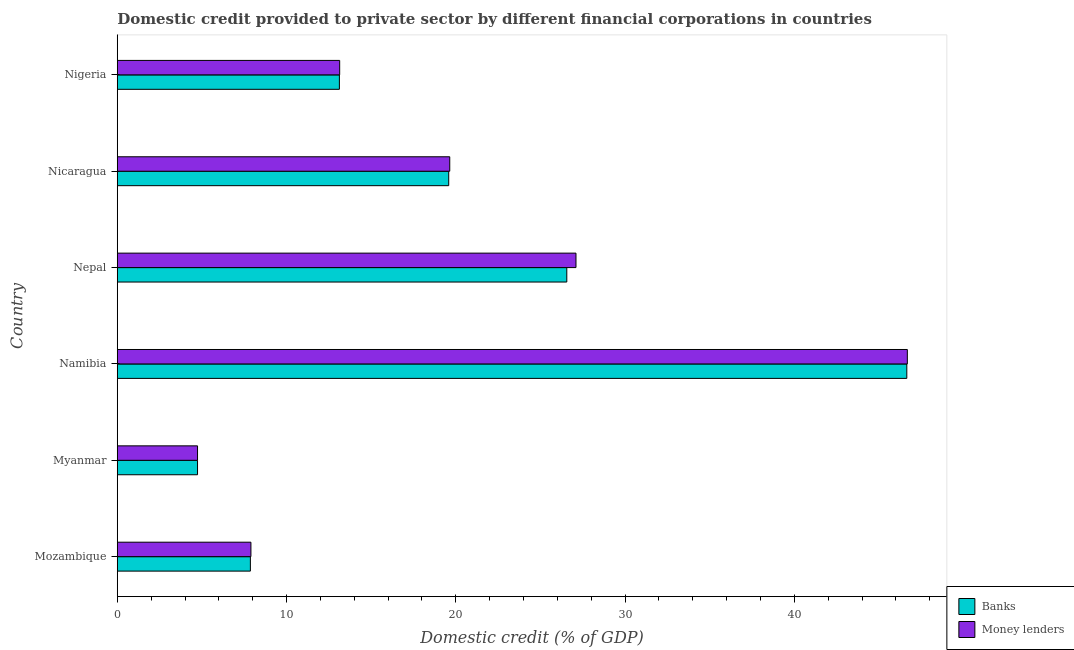How many different coloured bars are there?
Keep it short and to the point. 2. How many groups of bars are there?
Provide a short and direct response. 6. Are the number of bars per tick equal to the number of legend labels?
Provide a succinct answer. Yes. Are the number of bars on each tick of the Y-axis equal?
Provide a short and direct response. Yes. What is the label of the 6th group of bars from the top?
Offer a very short reply. Mozambique. In how many cases, is the number of bars for a given country not equal to the number of legend labels?
Ensure brevity in your answer.  0. What is the domestic credit provided by banks in Nicaragua?
Your answer should be compact. 19.58. Across all countries, what is the maximum domestic credit provided by money lenders?
Your response must be concise. 46.67. Across all countries, what is the minimum domestic credit provided by banks?
Give a very brief answer. 4.74. In which country was the domestic credit provided by money lenders maximum?
Keep it short and to the point. Namibia. In which country was the domestic credit provided by banks minimum?
Provide a short and direct response. Myanmar. What is the total domestic credit provided by money lenders in the graph?
Make the answer very short. 119.18. What is the difference between the domestic credit provided by banks in Mozambique and that in Nigeria?
Offer a terse response. -5.26. What is the difference between the domestic credit provided by money lenders in Nicaragua and the domestic credit provided by banks in Myanmar?
Your answer should be very brief. 14.9. What is the average domestic credit provided by money lenders per country?
Ensure brevity in your answer.  19.86. What is the difference between the domestic credit provided by money lenders and domestic credit provided by banks in Myanmar?
Provide a short and direct response. 0. What is the ratio of the domestic credit provided by money lenders in Myanmar to that in Namibia?
Your answer should be very brief. 0.1. Is the domestic credit provided by money lenders in Mozambique less than that in Nepal?
Provide a succinct answer. Yes. Is the difference between the domestic credit provided by money lenders in Mozambique and Myanmar greater than the difference between the domestic credit provided by banks in Mozambique and Myanmar?
Your answer should be very brief. Yes. What is the difference between the highest and the second highest domestic credit provided by banks?
Your answer should be very brief. 20.09. What is the difference between the highest and the lowest domestic credit provided by banks?
Make the answer very short. 41.9. Is the sum of the domestic credit provided by banks in Namibia and Nigeria greater than the maximum domestic credit provided by money lenders across all countries?
Your answer should be very brief. Yes. What does the 1st bar from the top in Myanmar represents?
Ensure brevity in your answer.  Money lenders. What does the 2nd bar from the bottom in Mozambique represents?
Provide a short and direct response. Money lenders. What is the difference between two consecutive major ticks on the X-axis?
Provide a short and direct response. 10. Does the graph contain any zero values?
Keep it short and to the point. No. Where does the legend appear in the graph?
Offer a terse response. Bottom right. How many legend labels are there?
Ensure brevity in your answer.  2. What is the title of the graph?
Your answer should be very brief. Domestic credit provided to private sector by different financial corporations in countries. What is the label or title of the X-axis?
Ensure brevity in your answer.  Domestic credit (% of GDP). What is the label or title of the Y-axis?
Your answer should be very brief. Country. What is the Domestic credit (% of GDP) in Banks in Mozambique?
Provide a succinct answer. 7.86. What is the Domestic credit (% of GDP) in Money lenders in Mozambique?
Your answer should be compact. 7.89. What is the Domestic credit (% of GDP) in Banks in Myanmar?
Your response must be concise. 4.74. What is the Domestic credit (% of GDP) in Money lenders in Myanmar?
Offer a terse response. 4.74. What is the Domestic credit (% of GDP) in Banks in Namibia?
Provide a succinct answer. 46.64. What is the Domestic credit (% of GDP) in Money lenders in Namibia?
Your response must be concise. 46.67. What is the Domestic credit (% of GDP) in Banks in Nepal?
Give a very brief answer. 26.55. What is the Domestic credit (% of GDP) of Money lenders in Nepal?
Provide a succinct answer. 27.1. What is the Domestic credit (% of GDP) in Banks in Nicaragua?
Your answer should be very brief. 19.58. What is the Domestic credit (% of GDP) in Money lenders in Nicaragua?
Offer a terse response. 19.64. What is the Domestic credit (% of GDP) of Banks in Nigeria?
Your answer should be compact. 13.12. What is the Domestic credit (% of GDP) of Money lenders in Nigeria?
Keep it short and to the point. 13.14. Across all countries, what is the maximum Domestic credit (% of GDP) in Banks?
Your response must be concise. 46.64. Across all countries, what is the maximum Domestic credit (% of GDP) in Money lenders?
Ensure brevity in your answer.  46.67. Across all countries, what is the minimum Domestic credit (% of GDP) in Banks?
Ensure brevity in your answer.  4.74. Across all countries, what is the minimum Domestic credit (% of GDP) in Money lenders?
Provide a succinct answer. 4.74. What is the total Domestic credit (% of GDP) in Banks in the graph?
Ensure brevity in your answer.  118.5. What is the total Domestic credit (% of GDP) of Money lenders in the graph?
Provide a succinct answer. 119.18. What is the difference between the Domestic credit (% of GDP) of Banks in Mozambique and that in Myanmar?
Ensure brevity in your answer.  3.12. What is the difference between the Domestic credit (% of GDP) in Money lenders in Mozambique and that in Myanmar?
Make the answer very short. 3.15. What is the difference between the Domestic credit (% of GDP) in Banks in Mozambique and that in Namibia?
Your answer should be compact. -38.78. What is the difference between the Domestic credit (% of GDP) of Money lenders in Mozambique and that in Namibia?
Make the answer very short. -38.78. What is the difference between the Domestic credit (% of GDP) in Banks in Mozambique and that in Nepal?
Your answer should be compact. -18.69. What is the difference between the Domestic credit (% of GDP) in Money lenders in Mozambique and that in Nepal?
Provide a succinct answer. -19.2. What is the difference between the Domestic credit (% of GDP) of Banks in Mozambique and that in Nicaragua?
Give a very brief answer. -11.72. What is the difference between the Domestic credit (% of GDP) of Money lenders in Mozambique and that in Nicaragua?
Provide a short and direct response. -11.75. What is the difference between the Domestic credit (% of GDP) of Banks in Mozambique and that in Nigeria?
Your response must be concise. -5.26. What is the difference between the Domestic credit (% of GDP) in Money lenders in Mozambique and that in Nigeria?
Provide a short and direct response. -5.24. What is the difference between the Domestic credit (% of GDP) of Banks in Myanmar and that in Namibia?
Make the answer very short. -41.9. What is the difference between the Domestic credit (% of GDP) of Money lenders in Myanmar and that in Namibia?
Provide a short and direct response. -41.93. What is the difference between the Domestic credit (% of GDP) of Banks in Myanmar and that in Nepal?
Ensure brevity in your answer.  -21.81. What is the difference between the Domestic credit (% of GDP) of Money lenders in Myanmar and that in Nepal?
Your answer should be very brief. -22.36. What is the difference between the Domestic credit (% of GDP) of Banks in Myanmar and that in Nicaragua?
Your response must be concise. -14.84. What is the difference between the Domestic credit (% of GDP) in Money lenders in Myanmar and that in Nicaragua?
Offer a terse response. -14.9. What is the difference between the Domestic credit (% of GDP) in Banks in Myanmar and that in Nigeria?
Make the answer very short. -8.38. What is the difference between the Domestic credit (% of GDP) in Money lenders in Myanmar and that in Nigeria?
Your answer should be compact. -8.4. What is the difference between the Domestic credit (% of GDP) of Banks in Namibia and that in Nepal?
Provide a short and direct response. 20.09. What is the difference between the Domestic credit (% of GDP) of Money lenders in Namibia and that in Nepal?
Your answer should be very brief. 19.57. What is the difference between the Domestic credit (% of GDP) in Banks in Namibia and that in Nicaragua?
Offer a terse response. 27.06. What is the difference between the Domestic credit (% of GDP) in Money lenders in Namibia and that in Nicaragua?
Ensure brevity in your answer.  27.03. What is the difference between the Domestic credit (% of GDP) of Banks in Namibia and that in Nigeria?
Your answer should be very brief. 33.52. What is the difference between the Domestic credit (% of GDP) of Money lenders in Namibia and that in Nigeria?
Provide a short and direct response. 33.53. What is the difference between the Domestic credit (% of GDP) of Banks in Nepal and that in Nicaragua?
Your answer should be very brief. 6.98. What is the difference between the Domestic credit (% of GDP) in Money lenders in Nepal and that in Nicaragua?
Keep it short and to the point. 7.46. What is the difference between the Domestic credit (% of GDP) of Banks in Nepal and that in Nigeria?
Keep it short and to the point. 13.43. What is the difference between the Domestic credit (% of GDP) in Money lenders in Nepal and that in Nigeria?
Your answer should be compact. 13.96. What is the difference between the Domestic credit (% of GDP) of Banks in Nicaragua and that in Nigeria?
Your answer should be very brief. 6.46. What is the difference between the Domestic credit (% of GDP) in Money lenders in Nicaragua and that in Nigeria?
Provide a succinct answer. 6.5. What is the difference between the Domestic credit (% of GDP) of Banks in Mozambique and the Domestic credit (% of GDP) of Money lenders in Myanmar?
Offer a terse response. 3.12. What is the difference between the Domestic credit (% of GDP) of Banks in Mozambique and the Domestic credit (% of GDP) of Money lenders in Namibia?
Ensure brevity in your answer.  -38.81. What is the difference between the Domestic credit (% of GDP) of Banks in Mozambique and the Domestic credit (% of GDP) of Money lenders in Nepal?
Ensure brevity in your answer.  -19.24. What is the difference between the Domestic credit (% of GDP) in Banks in Mozambique and the Domestic credit (% of GDP) in Money lenders in Nicaragua?
Give a very brief answer. -11.78. What is the difference between the Domestic credit (% of GDP) in Banks in Mozambique and the Domestic credit (% of GDP) in Money lenders in Nigeria?
Keep it short and to the point. -5.28. What is the difference between the Domestic credit (% of GDP) in Banks in Myanmar and the Domestic credit (% of GDP) in Money lenders in Namibia?
Offer a terse response. -41.93. What is the difference between the Domestic credit (% of GDP) of Banks in Myanmar and the Domestic credit (% of GDP) of Money lenders in Nepal?
Give a very brief answer. -22.36. What is the difference between the Domestic credit (% of GDP) of Banks in Myanmar and the Domestic credit (% of GDP) of Money lenders in Nicaragua?
Offer a terse response. -14.9. What is the difference between the Domestic credit (% of GDP) in Banks in Myanmar and the Domestic credit (% of GDP) in Money lenders in Nigeria?
Provide a short and direct response. -8.4. What is the difference between the Domestic credit (% of GDP) in Banks in Namibia and the Domestic credit (% of GDP) in Money lenders in Nepal?
Your response must be concise. 19.54. What is the difference between the Domestic credit (% of GDP) of Banks in Namibia and the Domestic credit (% of GDP) of Money lenders in Nicaragua?
Keep it short and to the point. 27. What is the difference between the Domestic credit (% of GDP) in Banks in Namibia and the Domestic credit (% of GDP) in Money lenders in Nigeria?
Make the answer very short. 33.5. What is the difference between the Domestic credit (% of GDP) of Banks in Nepal and the Domestic credit (% of GDP) of Money lenders in Nicaragua?
Your response must be concise. 6.91. What is the difference between the Domestic credit (% of GDP) in Banks in Nepal and the Domestic credit (% of GDP) in Money lenders in Nigeria?
Make the answer very short. 13.42. What is the difference between the Domestic credit (% of GDP) of Banks in Nicaragua and the Domestic credit (% of GDP) of Money lenders in Nigeria?
Keep it short and to the point. 6.44. What is the average Domestic credit (% of GDP) in Banks per country?
Offer a terse response. 19.75. What is the average Domestic credit (% of GDP) in Money lenders per country?
Your answer should be compact. 19.86. What is the difference between the Domestic credit (% of GDP) in Banks and Domestic credit (% of GDP) in Money lenders in Mozambique?
Your response must be concise. -0.03. What is the difference between the Domestic credit (% of GDP) in Banks and Domestic credit (% of GDP) in Money lenders in Myanmar?
Your answer should be compact. 0. What is the difference between the Domestic credit (% of GDP) of Banks and Domestic credit (% of GDP) of Money lenders in Namibia?
Provide a succinct answer. -0.03. What is the difference between the Domestic credit (% of GDP) of Banks and Domestic credit (% of GDP) of Money lenders in Nepal?
Keep it short and to the point. -0.54. What is the difference between the Domestic credit (% of GDP) of Banks and Domestic credit (% of GDP) of Money lenders in Nicaragua?
Keep it short and to the point. -0.06. What is the difference between the Domestic credit (% of GDP) in Banks and Domestic credit (% of GDP) in Money lenders in Nigeria?
Keep it short and to the point. -0.02. What is the ratio of the Domestic credit (% of GDP) of Banks in Mozambique to that in Myanmar?
Ensure brevity in your answer.  1.66. What is the ratio of the Domestic credit (% of GDP) in Money lenders in Mozambique to that in Myanmar?
Give a very brief answer. 1.67. What is the ratio of the Domestic credit (% of GDP) of Banks in Mozambique to that in Namibia?
Your response must be concise. 0.17. What is the ratio of the Domestic credit (% of GDP) of Money lenders in Mozambique to that in Namibia?
Keep it short and to the point. 0.17. What is the ratio of the Domestic credit (% of GDP) of Banks in Mozambique to that in Nepal?
Keep it short and to the point. 0.3. What is the ratio of the Domestic credit (% of GDP) of Money lenders in Mozambique to that in Nepal?
Make the answer very short. 0.29. What is the ratio of the Domestic credit (% of GDP) in Banks in Mozambique to that in Nicaragua?
Offer a very short reply. 0.4. What is the ratio of the Domestic credit (% of GDP) in Money lenders in Mozambique to that in Nicaragua?
Keep it short and to the point. 0.4. What is the ratio of the Domestic credit (% of GDP) in Banks in Mozambique to that in Nigeria?
Offer a very short reply. 0.6. What is the ratio of the Domestic credit (% of GDP) in Money lenders in Mozambique to that in Nigeria?
Provide a succinct answer. 0.6. What is the ratio of the Domestic credit (% of GDP) in Banks in Myanmar to that in Namibia?
Offer a very short reply. 0.1. What is the ratio of the Domestic credit (% of GDP) in Money lenders in Myanmar to that in Namibia?
Keep it short and to the point. 0.1. What is the ratio of the Domestic credit (% of GDP) in Banks in Myanmar to that in Nepal?
Provide a short and direct response. 0.18. What is the ratio of the Domestic credit (% of GDP) in Money lenders in Myanmar to that in Nepal?
Keep it short and to the point. 0.17. What is the ratio of the Domestic credit (% of GDP) of Banks in Myanmar to that in Nicaragua?
Ensure brevity in your answer.  0.24. What is the ratio of the Domestic credit (% of GDP) in Money lenders in Myanmar to that in Nicaragua?
Your answer should be compact. 0.24. What is the ratio of the Domestic credit (% of GDP) of Banks in Myanmar to that in Nigeria?
Keep it short and to the point. 0.36. What is the ratio of the Domestic credit (% of GDP) in Money lenders in Myanmar to that in Nigeria?
Your answer should be compact. 0.36. What is the ratio of the Domestic credit (% of GDP) of Banks in Namibia to that in Nepal?
Your response must be concise. 1.76. What is the ratio of the Domestic credit (% of GDP) in Money lenders in Namibia to that in Nepal?
Your response must be concise. 1.72. What is the ratio of the Domestic credit (% of GDP) of Banks in Namibia to that in Nicaragua?
Ensure brevity in your answer.  2.38. What is the ratio of the Domestic credit (% of GDP) in Money lenders in Namibia to that in Nicaragua?
Your answer should be very brief. 2.38. What is the ratio of the Domestic credit (% of GDP) of Banks in Namibia to that in Nigeria?
Offer a terse response. 3.55. What is the ratio of the Domestic credit (% of GDP) in Money lenders in Namibia to that in Nigeria?
Give a very brief answer. 3.55. What is the ratio of the Domestic credit (% of GDP) in Banks in Nepal to that in Nicaragua?
Offer a terse response. 1.36. What is the ratio of the Domestic credit (% of GDP) of Money lenders in Nepal to that in Nicaragua?
Give a very brief answer. 1.38. What is the ratio of the Domestic credit (% of GDP) in Banks in Nepal to that in Nigeria?
Your answer should be very brief. 2.02. What is the ratio of the Domestic credit (% of GDP) in Money lenders in Nepal to that in Nigeria?
Give a very brief answer. 2.06. What is the ratio of the Domestic credit (% of GDP) in Banks in Nicaragua to that in Nigeria?
Keep it short and to the point. 1.49. What is the ratio of the Domestic credit (% of GDP) in Money lenders in Nicaragua to that in Nigeria?
Keep it short and to the point. 1.49. What is the difference between the highest and the second highest Domestic credit (% of GDP) in Banks?
Your answer should be very brief. 20.09. What is the difference between the highest and the second highest Domestic credit (% of GDP) of Money lenders?
Your response must be concise. 19.57. What is the difference between the highest and the lowest Domestic credit (% of GDP) in Banks?
Your response must be concise. 41.9. What is the difference between the highest and the lowest Domestic credit (% of GDP) in Money lenders?
Provide a succinct answer. 41.93. 